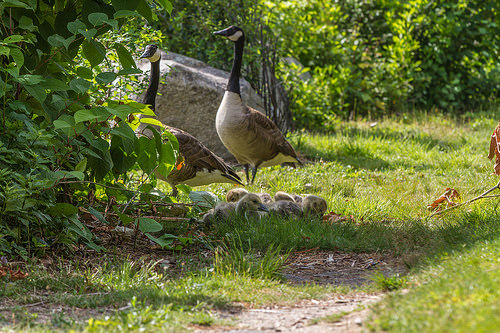<image>
Is the goose on the rock? No. The goose is not positioned on the rock. They may be near each other, but the goose is not supported by or resting on top of the rock. 